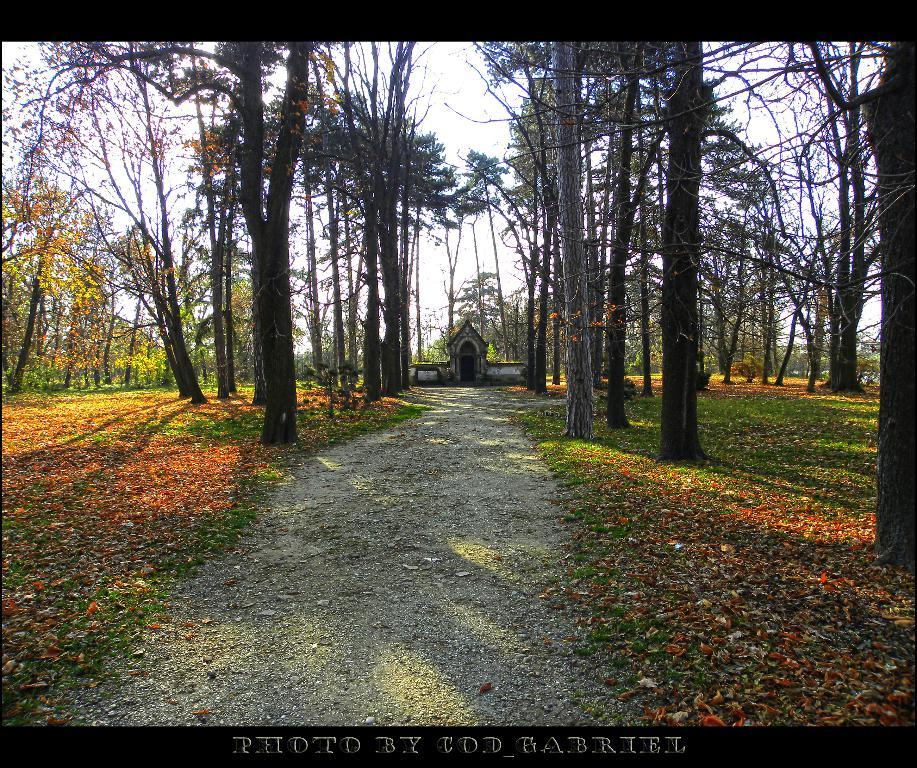What type of vegetation can be seen in the image? There are trees with branches and leaves in the image. What type of structure is visible in the image? There appears to be a house in the image. What can be used for walking or traveling in the image? There is a pathway in the image. What is present on the grass in the image? Leaves are lying on the grass in the image. Is there any indication of the image's origin or ownership? There is a watermark on the image. What type of humor can be seen in the image? There is no humor present in the image; it features trees, a house, a pathway, leaves on the grass, and a watermark. What type of rod is used to measure the distance between the trees in the image? There is no rod or measurement of distance between trees in the image. 